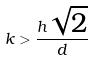Convert formula to latex. <formula><loc_0><loc_0><loc_500><loc_500>k > \frac { h \sqrt { 2 } } { d }</formula> 